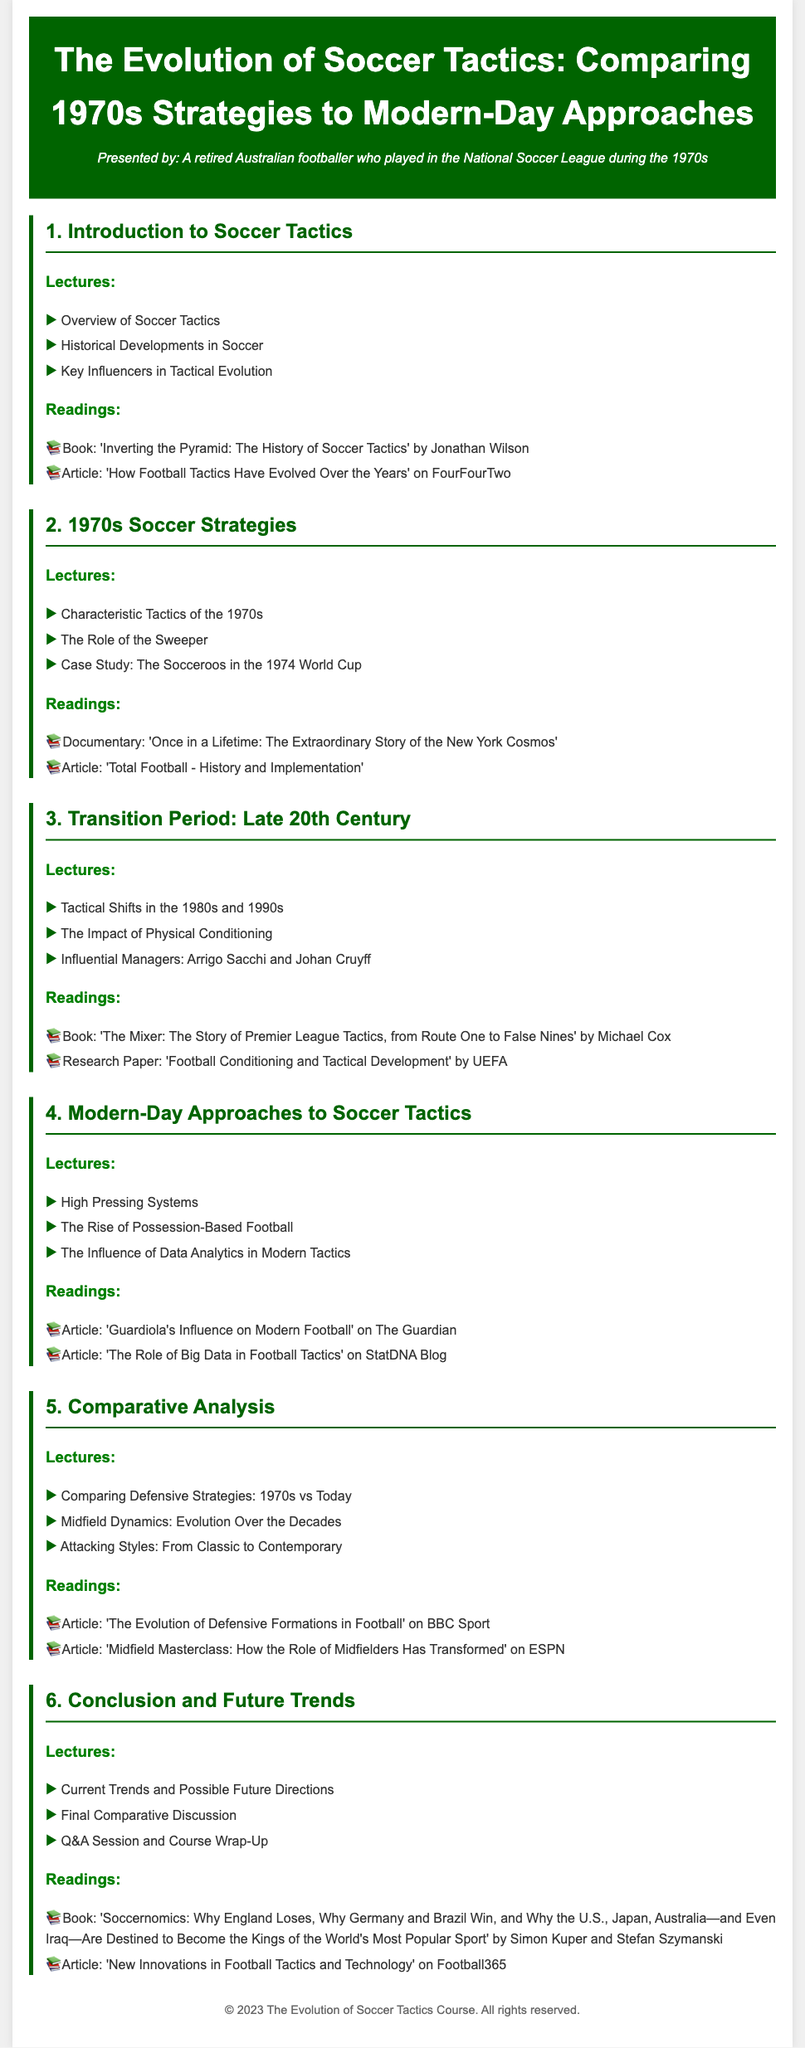What is the title of the syllabus? The title of the syllabus is stated at the beginning of the document, emphasizing the focus on soccer tactics over time.
Answer: The Evolution of Soccer Tactics: Comparing 1970s Strategies to Modern-Day Approaches Who wrote the book 'Inverting the Pyramid'? The document includes a reading list where the author of the book 'Inverting the Pyramid' is mentioned, providing specific information.
Answer: Jonathan Wilson What characteristic tactic is discussed in the 1970s strategies? The syllabus outlines specific lectures that focus on tactics from the 1970s, highlighting key features of the period.
Answer: Characteristic Tactics of the 1970s Which influential manager is associated with the transition period? The document lists influential managers during the transition period, indicating their significance in the evolution of tactics.
Answer: Arrigo Sacchi How many modules are included in the syllabus? The document is structured into various modules, and counting them provides a clear answer to this question.
Answer: Six What reading material is suggested for modern-day approaches to soccer tactics? The syllabus details readings associated with modern tactics, specifically mentioning articles related to contemporary strategies.
Answer: Article: 'Guardiola's Influence on Modern Football' on The Guardian What type of football is on the rise according to modern-day approaches? The document describes specific trends in modern football, highlighting the strategies that have become more prevalent.
Answer: Possession-Based Football What is the focus of the final module in the syllabus? The syllabus outlines the content of the last module, indicating what will be discussed and wrapped up at the end of the course.
Answer: Current Trends and Possible Future Directions 